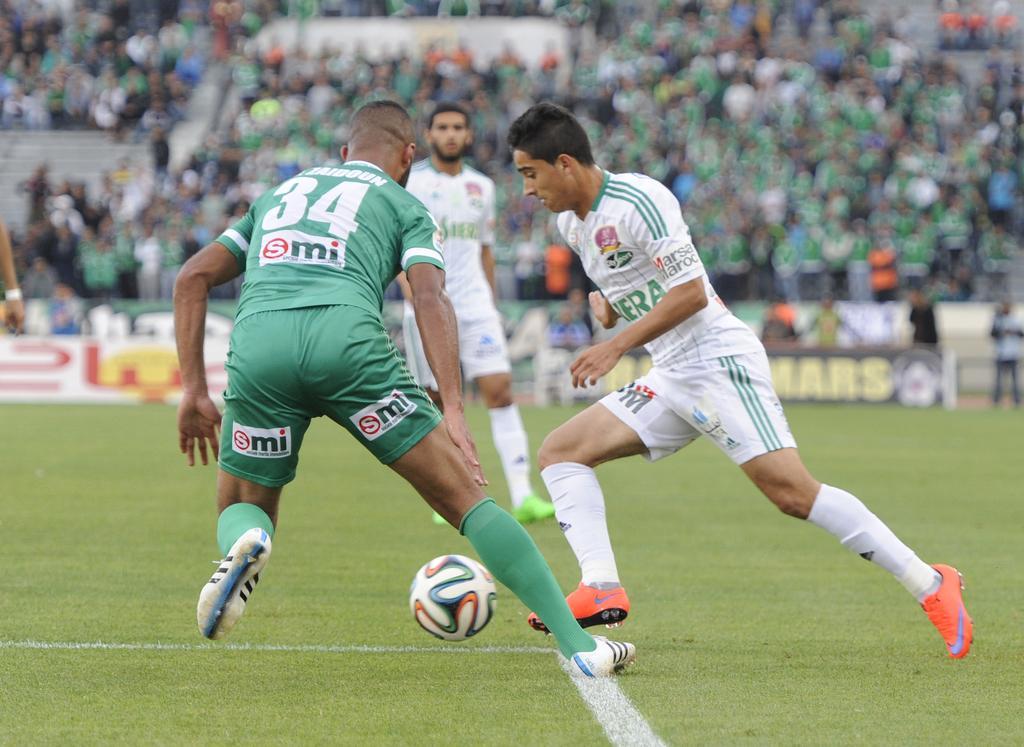In one or two sentences, can you explain what this image depicts? The man in green T-shirt and two men in white T-shirts are playing football. In front of them, we see a white ball. At the bottom of the picture, we see the grass. In the background, we see the boards in white, green and brown color with some text written on it. In the background, there are many people. This picture might be clicked in the football stadium. This picture is blurred in the background. 